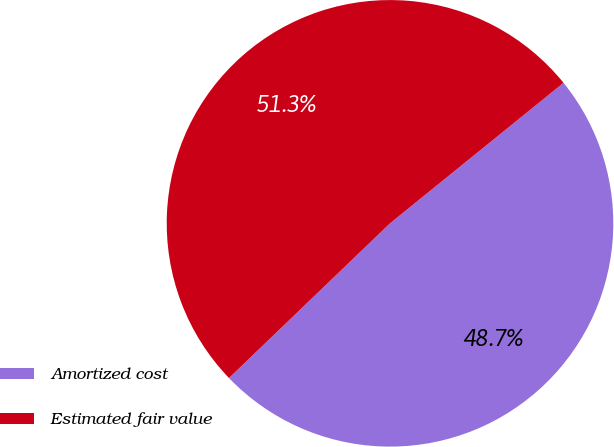Convert chart. <chart><loc_0><loc_0><loc_500><loc_500><pie_chart><fcel>Amortized cost<fcel>Estimated fair value<nl><fcel>48.65%<fcel>51.35%<nl></chart> 